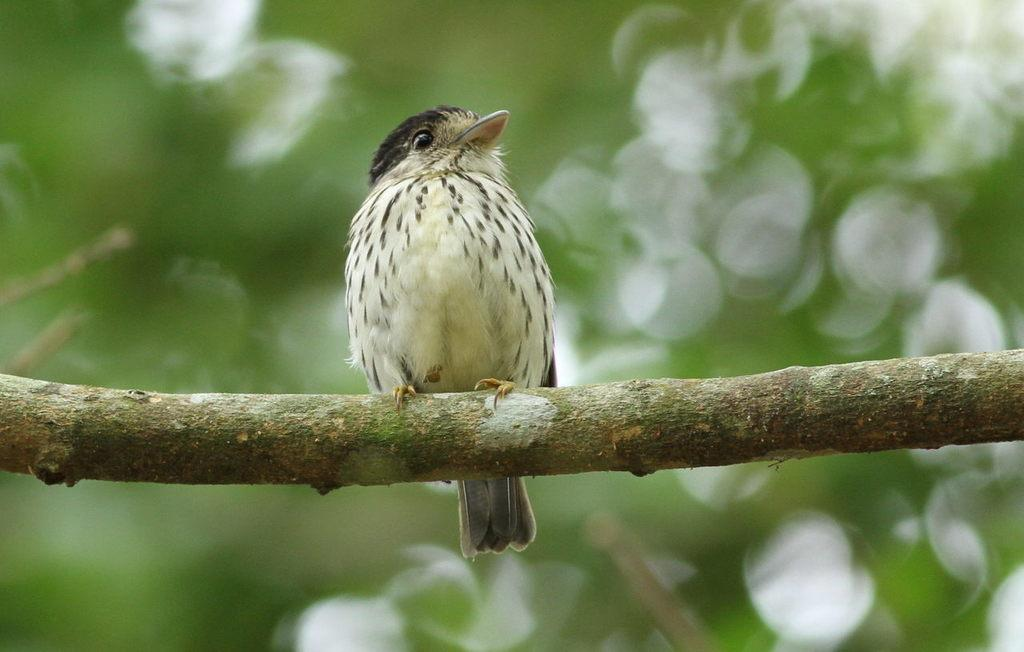What type of animal is in the image? There is a bird in the image. Where is the bird located in the image? The bird is in the front of the image. What can be observed about the background of the image? The background of the image is blurred. What type of pie is the bird holding in the image? There is no pie present in the image, and the bird is not holding anything. What type of condition does the bird have in the image? There is no indication of any specific condition of the bird in the image. 